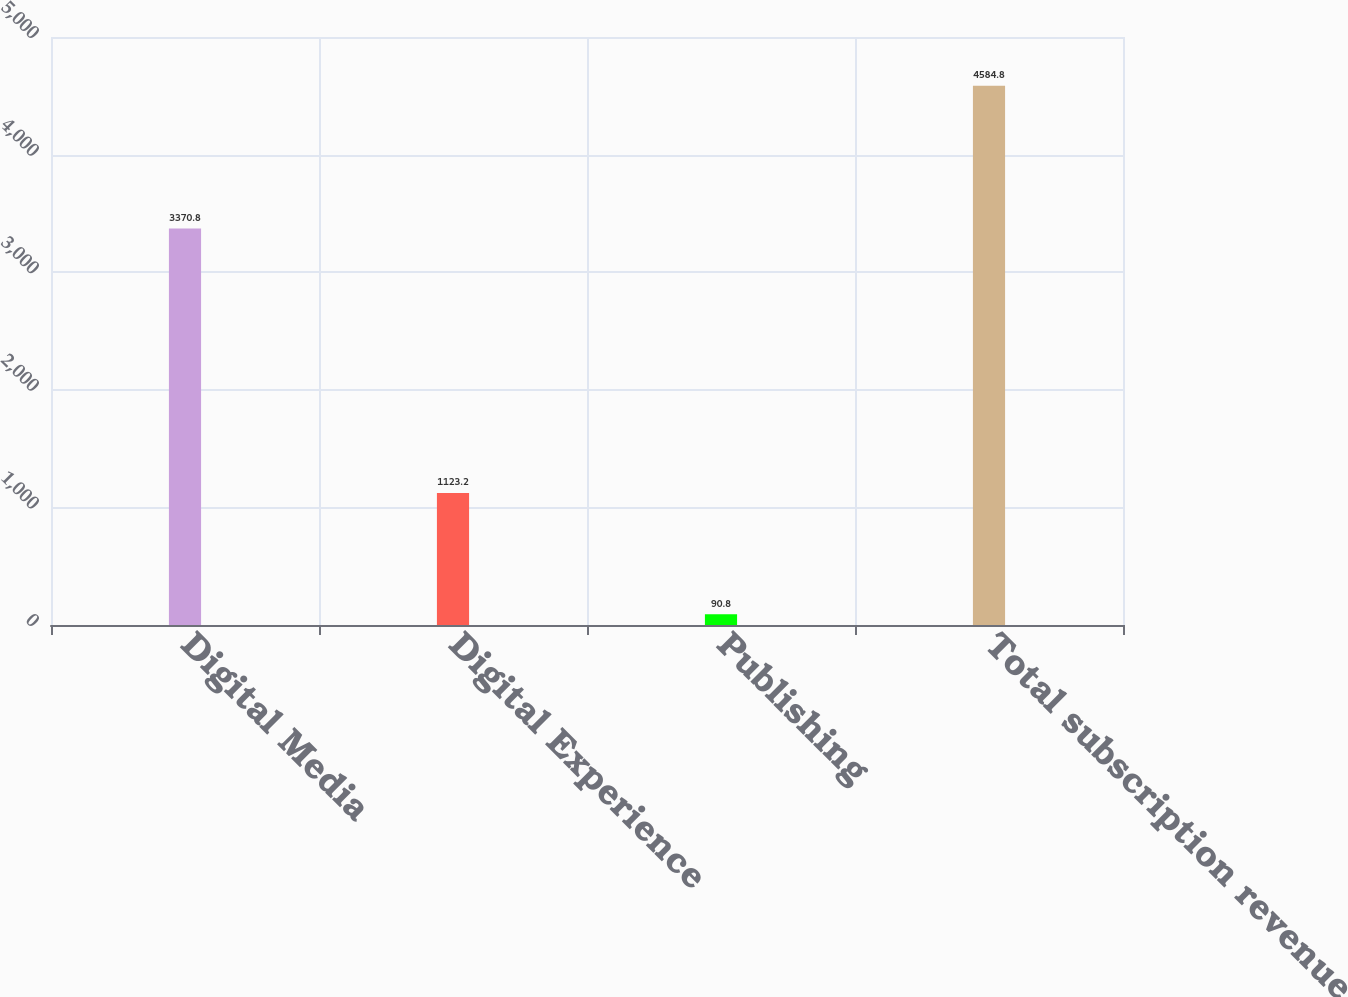Convert chart. <chart><loc_0><loc_0><loc_500><loc_500><bar_chart><fcel>Digital Media<fcel>Digital Experience<fcel>Publishing<fcel>Total subscription revenue<nl><fcel>3370.8<fcel>1123.2<fcel>90.8<fcel>4584.8<nl></chart> 